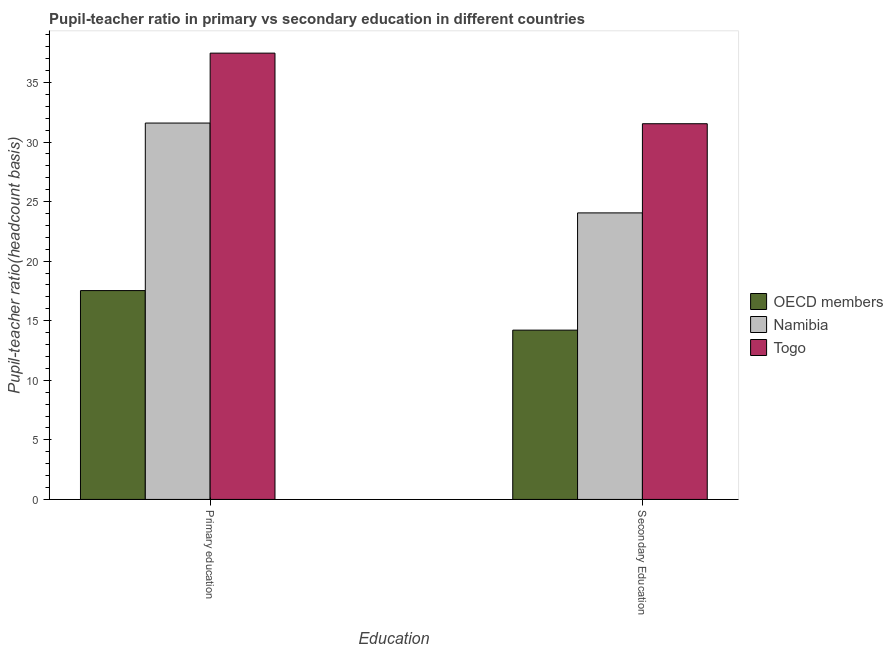How many bars are there on the 2nd tick from the left?
Keep it short and to the point. 3. What is the pupil teacher ratio on secondary education in OECD members?
Offer a very short reply. 14.21. Across all countries, what is the maximum pupil-teacher ratio in primary education?
Offer a very short reply. 37.46. Across all countries, what is the minimum pupil teacher ratio on secondary education?
Ensure brevity in your answer.  14.21. In which country was the pupil teacher ratio on secondary education maximum?
Make the answer very short. Togo. What is the total pupil teacher ratio on secondary education in the graph?
Your response must be concise. 69.8. What is the difference between the pupil-teacher ratio in primary education in Togo and that in Namibia?
Your answer should be compact. 5.87. What is the difference between the pupil teacher ratio on secondary education in OECD members and the pupil-teacher ratio in primary education in Togo?
Provide a short and direct response. -23.25. What is the average pupil-teacher ratio in primary education per country?
Offer a terse response. 28.86. What is the difference between the pupil-teacher ratio in primary education and pupil teacher ratio on secondary education in OECD members?
Provide a short and direct response. 3.32. What is the ratio of the pupil-teacher ratio in primary education in Togo to that in OECD members?
Provide a succinct answer. 2.14. Is the pupil teacher ratio on secondary education in Togo less than that in OECD members?
Keep it short and to the point. No. What does the 1st bar from the left in Primary education represents?
Provide a succinct answer. OECD members. What does the 1st bar from the right in Secondary Education represents?
Provide a succinct answer. Togo. Are the values on the major ticks of Y-axis written in scientific E-notation?
Your answer should be very brief. No. What is the title of the graph?
Give a very brief answer. Pupil-teacher ratio in primary vs secondary education in different countries. Does "High income: OECD" appear as one of the legend labels in the graph?
Make the answer very short. No. What is the label or title of the X-axis?
Provide a short and direct response. Education. What is the label or title of the Y-axis?
Provide a short and direct response. Pupil-teacher ratio(headcount basis). What is the Pupil-teacher ratio(headcount basis) in OECD members in Primary education?
Offer a terse response. 17.53. What is the Pupil-teacher ratio(headcount basis) in Namibia in Primary education?
Your answer should be compact. 31.59. What is the Pupil-teacher ratio(headcount basis) of Togo in Primary education?
Your answer should be compact. 37.46. What is the Pupil-teacher ratio(headcount basis) in OECD members in Secondary Education?
Provide a short and direct response. 14.21. What is the Pupil-teacher ratio(headcount basis) of Namibia in Secondary Education?
Your answer should be compact. 24.05. What is the Pupil-teacher ratio(headcount basis) in Togo in Secondary Education?
Keep it short and to the point. 31.53. Across all Education, what is the maximum Pupil-teacher ratio(headcount basis) in OECD members?
Provide a succinct answer. 17.53. Across all Education, what is the maximum Pupil-teacher ratio(headcount basis) of Namibia?
Provide a succinct answer. 31.59. Across all Education, what is the maximum Pupil-teacher ratio(headcount basis) in Togo?
Offer a terse response. 37.46. Across all Education, what is the minimum Pupil-teacher ratio(headcount basis) of OECD members?
Give a very brief answer. 14.21. Across all Education, what is the minimum Pupil-teacher ratio(headcount basis) of Namibia?
Your answer should be compact. 24.05. Across all Education, what is the minimum Pupil-teacher ratio(headcount basis) of Togo?
Provide a short and direct response. 31.53. What is the total Pupil-teacher ratio(headcount basis) in OECD members in the graph?
Your answer should be very brief. 31.74. What is the total Pupil-teacher ratio(headcount basis) of Namibia in the graph?
Provide a short and direct response. 55.64. What is the total Pupil-teacher ratio(headcount basis) of Togo in the graph?
Offer a terse response. 68.99. What is the difference between the Pupil-teacher ratio(headcount basis) in OECD members in Primary education and that in Secondary Education?
Your answer should be compact. 3.32. What is the difference between the Pupil-teacher ratio(headcount basis) in Namibia in Primary education and that in Secondary Education?
Give a very brief answer. 7.54. What is the difference between the Pupil-teacher ratio(headcount basis) of Togo in Primary education and that in Secondary Education?
Keep it short and to the point. 5.93. What is the difference between the Pupil-teacher ratio(headcount basis) in OECD members in Primary education and the Pupil-teacher ratio(headcount basis) in Namibia in Secondary Education?
Ensure brevity in your answer.  -6.52. What is the difference between the Pupil-teacher ratio(headcount basis) of OECD members in Primary education and the Pupil-teacher ratio(headcount basis) of Togo in Secondary Education?
Keep it short and to the point. -14.01. What is the difference between the Pupil-teacher ratio(headcount basis) in Namibia in Primary education and the Pupil-teacher ratio(headcount basis) in Togo in Secondary Education?
Ensure brevity in your answer.  0.06. What is the average Pupil-teacher ratio(headcount basis) of OECD members per Education?
Keep it short and to the point. 15.87. What is the average Pupil-teacher ratio(headcount basis) of Namibia per Education?
Your answer should be very brief. 27.82. What is the average Pupil-teacher ratio(headcount basis) in Togo per Education?
Your answer should be very brief. 34.5. What is the difference between the Pupil-teacher ratio(headcount basis) of OECD members and Pupil-teacher ratio(headcount basis) of Namibia in Primary education?
Your answer should be compact. -14.06. What is the difference between the Pupil-teacher ratio(headcount basis) in OECD members and Pupil-teacher ratio(headcount basis) in Togo in Primary education?
Make the answer very short. -19.93. What is the difference between the Pupil-teacher ratio(headcount basis) of Namibia and Pupil-teacher ratio(headcount basis) of Togo in Primary education?
Keep it short and to the point. -5.87. What is the difference between the Pupil-teacher ratio(headcount basis) of OECD members and Pupil-teacher ratio(headcount basis) of Namibia in Secondary Education?
Offer a very short reply. -9.84. What is the difference between the Pupil-teacher ratio(headcount basis) in OECD members and Pupil-teacher ratio(headcount basis) in Togo in Secondary Education?
Make the answer very short. -17.32. What is the difference between the Pupil-teacher ratio(headcount basis) in Namibia and Pupil-teacher ratio(headcount basis) in Togo in Secondary Education?
Offer a very short reply. -7.48. What is the ratio of the Pupil-teacher ratio(headcount basis) in OECD members in Primary education to that in Secondary Education?
Your response must be concise. 1.23. What is the ratio of the Pupil-teacher ratio(headcount basis) in Namibia in Primary education to that in Secondary Education?
Provide a succinct answer. 1.31. What is the ratio of the Pupil-teacher ratio(headcount basis) in Togo in Primary education to that in Secondary Education?
Your answer should be very brief. 1.19. What is the difference between the highest and the second highest Pupil-teacher ratio(headcount basis) of OECD members?
Ensure brevity in your answer.  3.32. What is the difference between the highest and the second highest Pupil-teacher ratio(headcount basis) of Namibia?
Your answer should be very brief. 7.54. What is the difference between the highest and the second highest Pupil-teacher ratio(headcount basis) of Togo?
Offer a terse response. 5.93. What is the difference between the highest and the lowest Pupil-teacher ratio(headcount basis) of OECD members?
Ensure brevity in your answer.  3.32. What is the difference between the highest and the lowest Pupil-teacher ratio(headcount basis) in Namibia?
Provide a short and direct response. 7.54. What is the difference between the highest and the lowest Pupil-teacher ratio(headcount basis) in Togo?
Keep it short and to the point. 5.93. 